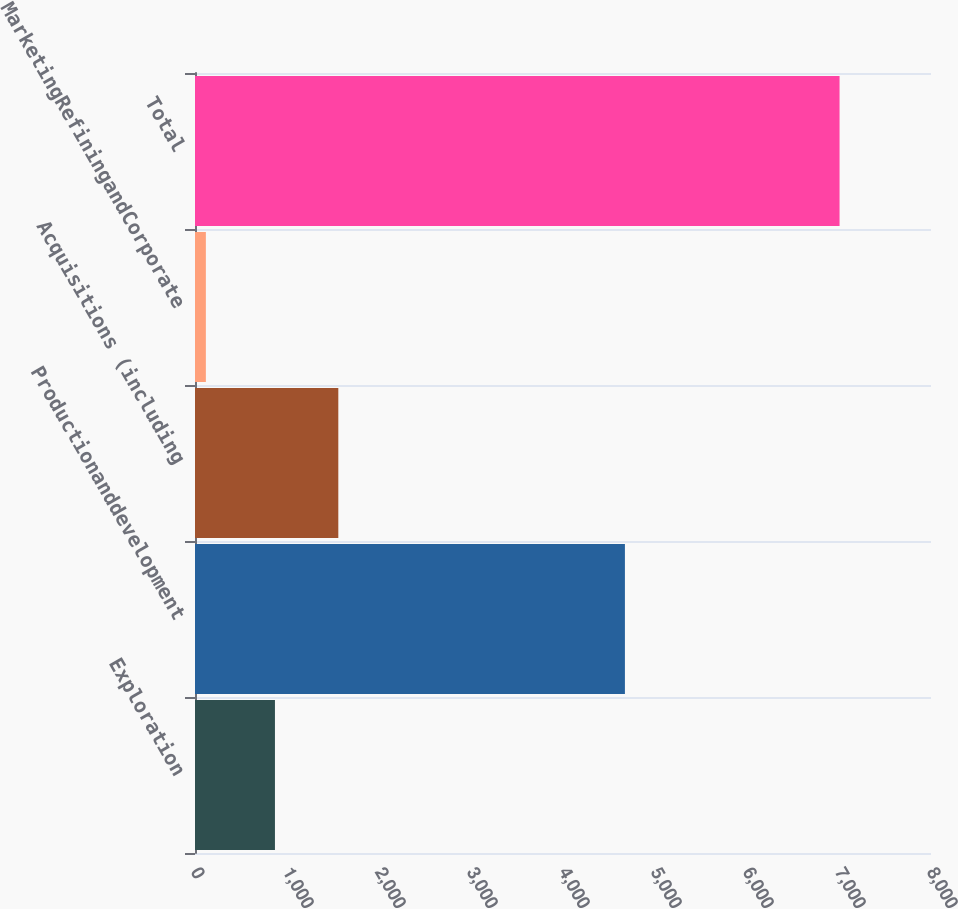Convert chart to OTSL. <chart><loc_0><loc_0><loc_500><loc_500><bar_chart><fcel>Exploration<fcel>Productionanddevelopment<fcel>Acquisitions (including<fcel>MarketingRefiningandCorporate<fcel>Total<nl><fcel>869<fcel>4673<fcel>1557.8<fcel>118<fcel>7006<nl></chart> 